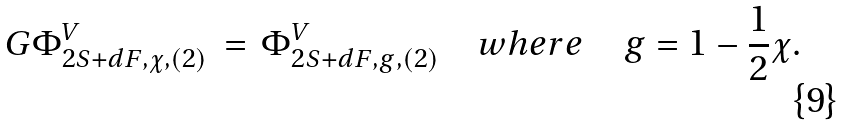Convert formula to latex. <formula><loc_0><loc_0><loc_500><loc_500>G \Phi ^ { V } _ { 2 S + d F , \chi , ( 2 ) } \, = \, \Phi ^ { V } _ { 2 S + d F , g , ( 2 ) } \quad w h e r e \quad g = 1 - \frac { 1 } { 2 } \chi .</formula> 